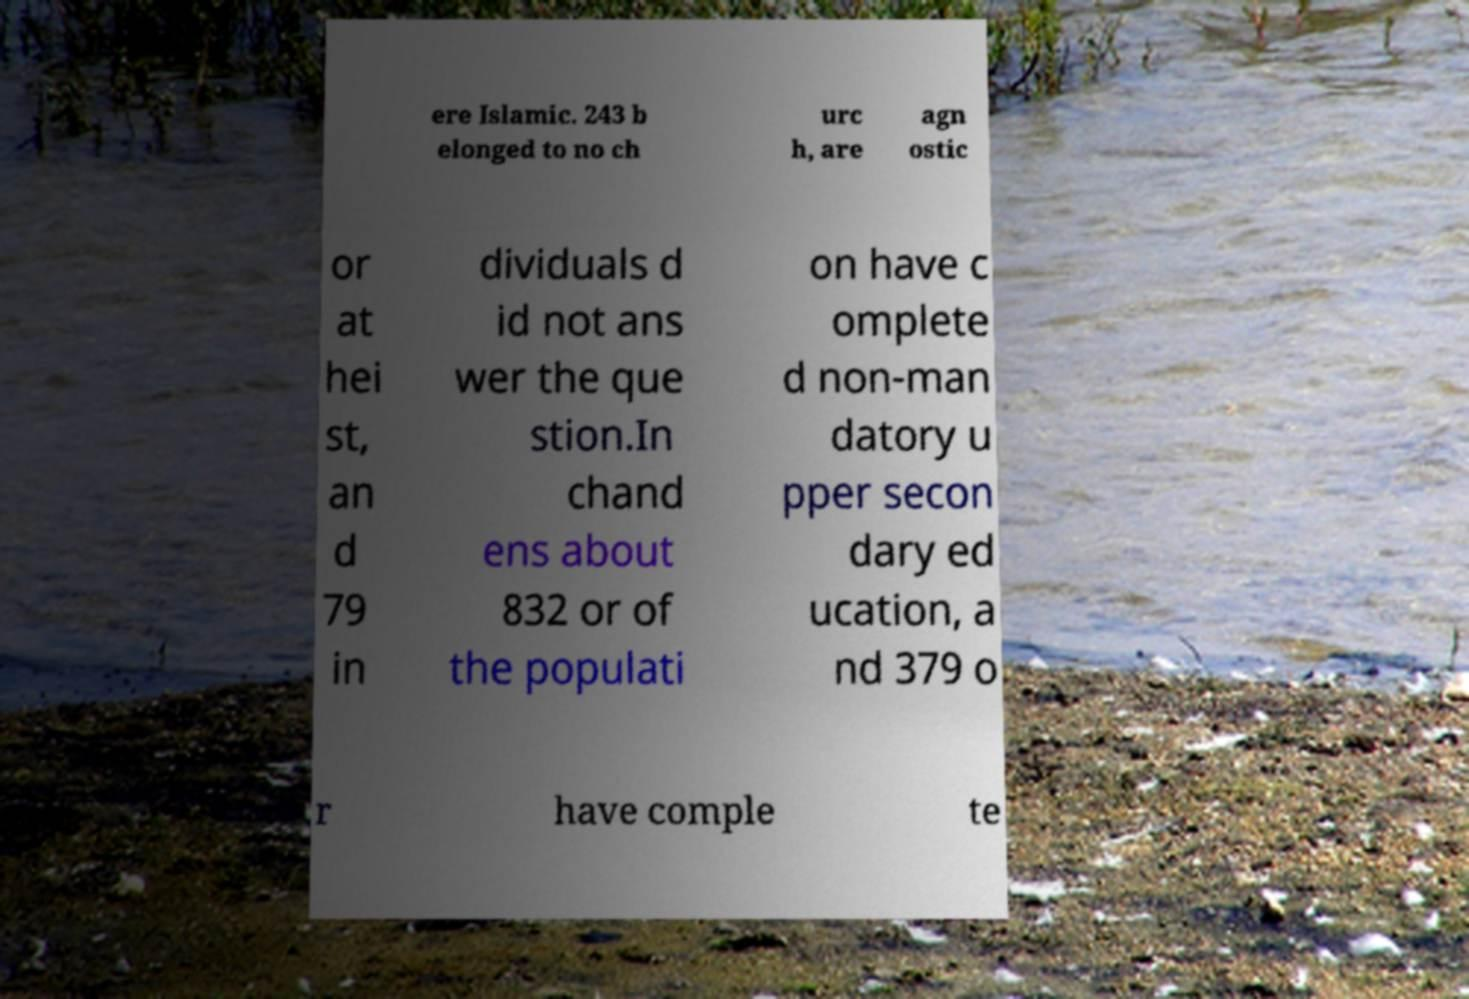There's text embedded in this image that I need extracted. Can you transcribe it verbatim? ere Islamic. 243 b elonged to no ch urc h, are agn ostic or at hei st, an d 79 in dividuals d id not ans wer the que stion.In chand ens about 832 or of the populati on have c omplete d non-man datory u pper secon dary ed ucation, a nd 379 o r have comple te 